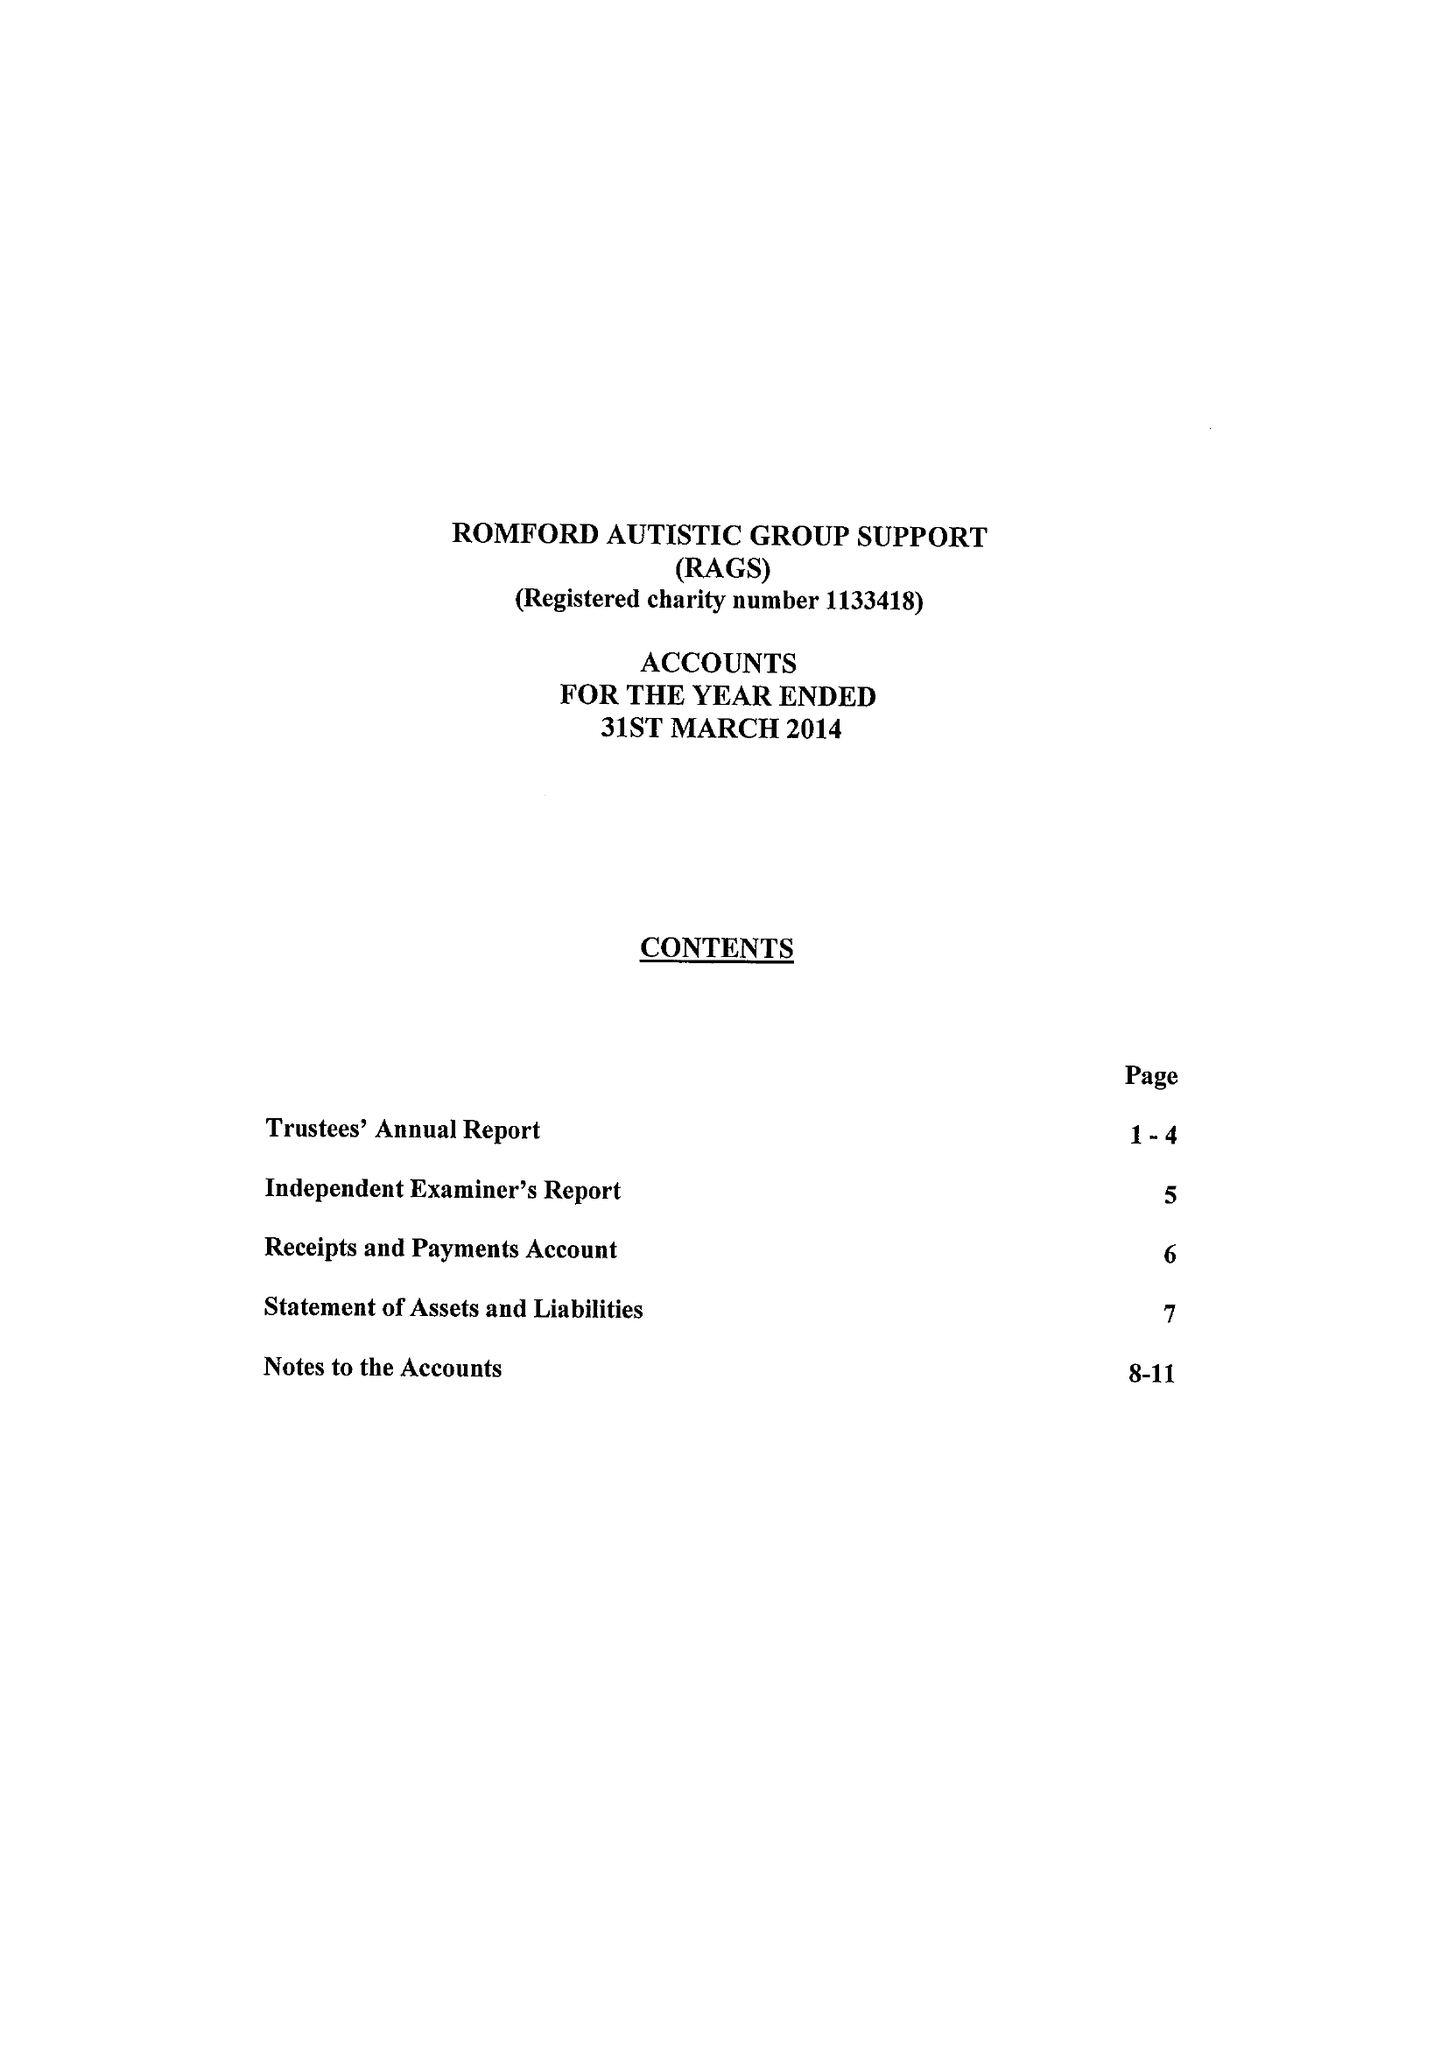What is the value for the charity_name?
Answer the question using a single word or phrase. Romford Autistic Group Support 